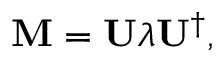<formula> <loc_0><loc_0><loc_500><loc_500>M = U \lambda U ^ { \dagger } ,</formula> 